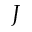<formula> <loc_0><loc_0><loc_500><loc_500>J</formula> 